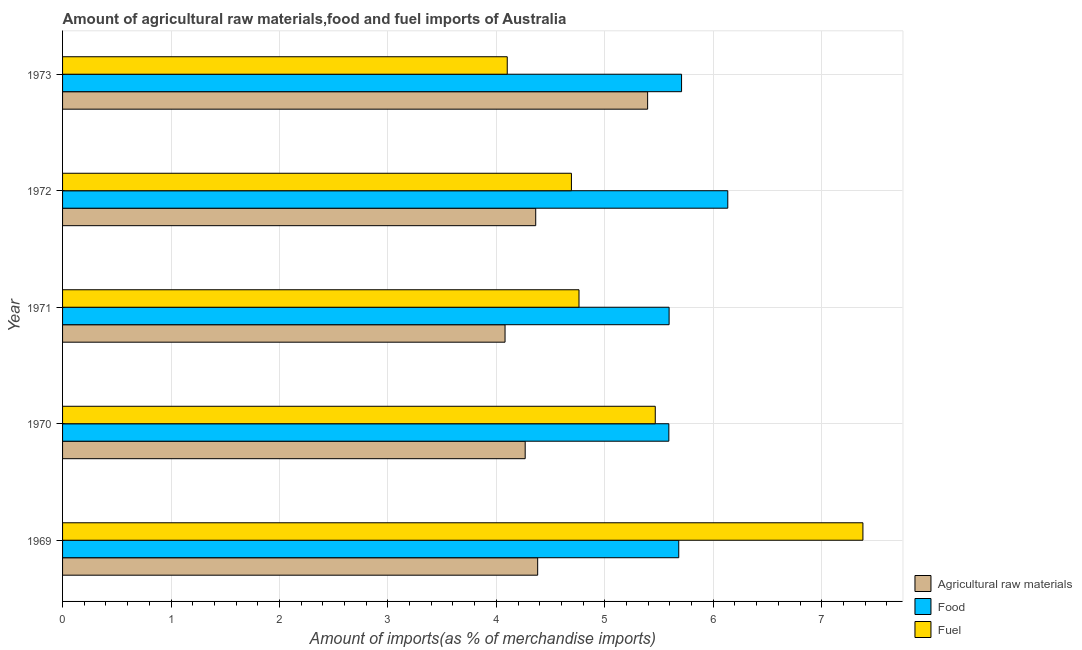How many groups of bars are there?
Keep it short and to the point. 5. Are the number of bars per tick equal to the number of legend labels?
Make the answer very short. Yes. How many bars are there on the 1st tick from the top?
Offer a terse response. 3. How many bars are there on the 4th tick from the bottom?
Keep it short and to the point. 3. What is the label of the 1st group of bars from the top?
Give a very brief answer. 1973. What is the percentage of fuel imports in 1972?
Your response must be concise. 4.69. Across all years, what is the maximum percentage of food imports?
Provide a short and direct response. 6.13. Across all years, what is the minimum percentage of fuel imports?
Provide a short and direct response. 4.1. In which year was the percentage of fuel imports maximum?
Offer a terse response. 1969. What is the total percentage of fuel imports in the graph?
Ensure brevity in your answer.  26.4. What is the difference between the percentage of raw materials imports in 1970 and that in 1971?
Ensure brevity in your answer.  0.19. What is the difference between the percentage of raw materials imports in 1971 and the percentage of fuel imports in 1973?
Provide a short and direct response. -0.02. What is the average percentage of raw materials imports per year?
Offer a very short reply. 4.5. In the year 1973, what is the difference between the percentage of food imports and percentage of raw materials imports?
Give a very brief answer. 0.31. In how many years, is the percentage of raw materials imports greater than 1.6 %?
Give a very brief answer. 5. What is the ratio of the percentage of food imports in 1970 to that in 1972?
Offer a terse response. 0.91. Is the difference between the percentage of food imports in 1969 and 1971 greater than the difference between the percentage of raw materials imports in 1969 and 1971?
Your answer should be very brief. No. What is the difference between the highest and the second highest percentage of food imports?
Your response must be concise. 0.43. What is the difference between the highest and the lowest percentage of fuel imports?
Your answer should be compact. 3.28. Is the sum of the percentage of food imports in 1971 and 1972 greater than the maximum percentage of raw materials imports across all years?
Provide a short and direct response. Yes. What does the 2nd bar from the top in 1970 represents?
Your response must be concise. Food. What does the 3rd bar from the bottom in 1971 represents?
Your answer should be very brief. Fuel. Is it the case that in every year, the sum of the percentage of raw materials imports and percentage of food imports is greater than the percentage of fuel imports?
Your answer should be very brief. Yes. How many bars are there?
Provide a short and direct response. 15. How many years are there in the graph?
Make the answer very short. 5. What is the difference between two consecutive major ticks on the X-axis?
Make the answer very short. 1. Are the values on the major ticks of X-axis written in scientific E-notation?
Make the answer very short. No. Does the graph contain any zero values?
Give a very brief answer. No. Does the graph contain grids?
Ensure brevity in your answer.  Yes. How many legend labels are there?
Offer a very short reply. 3. How are the legend labels stacked?
Give a very brief answer. Vertical. What is the title of the graph?
Your answer should be very brief. Amount of agricultural raw materials,food and fuel imports of Australia. Does "Domestic economy" appear as one of the legend labels in the graph?
Offer a terse response. No. What is the label or title of the X-axis?
Your response must be concise. Amount of imports(as % of merchandise imports). What is the label or title of the Y-axis?
Offer a terse response. Year. What is the Amount of imports(as % of merchandise imports) of Agricultural raw materials in 1969?
Offer a very short reply. 4.38. What is the Amount of imports(as % of merchandise imports) of Food in 1969?
Provide a short and direct response. 5.68. What is the Amount of imports(as % of merchandise imports) in Fuel in 1969?
Your answer should be very brief. 7.38. What is the Amount of imports(as % of merchandise imports) of Agricultural raw materials in 1970?
Offer a very short reply. 4.27. What is the Amount of imports(as % of merchandise imports) of Food in 1970?
Keep it short and to the point. 5.59. What is the Amount of imports(as % of merchandise imports) of Fuel in 1970?
Keep it short and to the point. 5.47. What is the Amount of imports(as % of merchandise imports) of Agricultural raw materials in 1971?
Offer a terse response. 4.08. What is the Amount of imports(as % of merchandise imports) in Food in 1971?
Offer a terse response. 5.59. What is the Amount of imports(as % of merchandise imports) in Fuel in 1971?
Make the answer very short. 4.76. What is the Amount of imports(as % of merchandise imports) of Agricultural raw materials in 1972?
Keep it short and to the point. 4.36. What is the Amount of imports(as % of merchandise imports) in Food in 1972?
Your answer should be very brief. 6.13. What is the Amount of imports(as % of merchandise imports) in Fuel in 1972?
Your response must be concise. 4.69. What is the Amount of imports(as % of merchandise imports) in Agricultural raw materials in 1973?
Offer a very short reply. 5.39. What is the Amount of imports(as % of merchandise imports) of Food in 1973?
Keep it short and to the point. 5.71. What is the Amount of imports(as % of merchandise imports) of Fuel in 1973?
Ensure brevity in your answer.  4.1. Across all years, what is the maximum Amount of imports(as % of merchandise imports) in Agricultural raw materials?
Offer a terse response. 5.39. Across all years, what is the maximum Amount of imports(as % of merchandise imports) in Food?
Your answer should be very brief. 6.13. Across all years, what is the maximum Amount of imports(as % of merchandise imports) in Fuel?
Your answer should be very brief. 7.38. Across all years, what is the minimum Amount of imports(as % of merchandise imports) of Agricultural raw materials?
Your answer should be very brief. 4.08. Across all years, what is the minimum Amount of imports(as % of merchandise imports) in Food?
Your answer should be compact. 5.59. Across all years, what is the minimum Amount of imports(as % of merchandise imports) of Fuel?
Your response must be concise. 4.1. What is the total Amount of imports(as % of merchandise imports) of Agricultural raw materials in the graph?
Keep it short and to the point. 22.48. What is the total Amount of imports(as % of merchandise imports) in Food in the graph?
Ensure brevity in your answer.  28.71. What is the total Amount of imports(as % of merchandise imports) in Fuel in the graph?
Your answer should be compact. 26.4. What is the difference between the Amount of imports(as % of merchandise imports) in Agricultural raw materials in 1969 and that in 1970?
Keep it short and to the point. 0.12. What is the difference between the Amount of imports(as % of merchandise imports) in Food in 1969 and that in 1970?
Your answer should be compact. 0.09. What is the difference between the Amount of imports(as % of merchandise imports) of Fuel in 1969 and that in 1970?
Ensure brevity in your answer.  1.91. What is the difference between the Amount of imports(as % of merchandise imports) of Agricultural raw materials in 1969 and that in 1971?
Keep it short and to the point. 0.3. What is the difference between the Amount of imports(as % of merchandise imports) of Food in 1969 and that in 1971?
Your answer should be very brief. 0.09. What is the difference between the Amount of imports(as % of merchandise imports) in Fuel in 1969 and that in 1971?
Ensure brevity in your answer.  2.62. What is the difference between the Amount of imports(as % of merchandise imports) in Agricultural raw materials in 1969 and that in 1972?
Keep it short and to the point. 0.02. What is the difference between the Amount of imports(as % of merchandise imports) of Food in 1969 and that in 1972?
Give a very brief answer. -0.45. What is the difference between the Amount of imports(as % of merchandise imports) in Fuel in 1969 and that in 1972?
Your answer should be very brief. 2.69. What is the difference between the Amount of imports(as % of merchandise imports) in Agricultural raw materials in 1969 and that in 1973?
Make the answer very short. -1.01. What is the difference between the Amount of imports(as % of merchandise imports) in Food in 1969 and that in 1973?
Ensure brevity in your answer.  -0.03. What is the difference between the Amount of imports(as % of merchandise imports) of Fuel in 1969 and that in 1973?
Offer a terse response. 3.28. What is the difference between the Amount of imports(as % of merchandise imports) in Agricultural raw materials in 1970 and that in 1971?
Give a very brief answer. 0.19. What is the difference between the Amount of imports(as % of merchandise imports) in Food in 1970 and that in 1971?
Your answer should be very brief. -0. What is the difference between the Amount of imports(as % of merchandise imports) in Fuel in 1970 and that in 1971?
Provide a short and direct response. 0.7. What is the difference between the Amount of imports(as % of merchandise imports) of Agricultural raw materials in 1970 and that in 1972?
Keep it short and to the point. -0.1. What is the difference between the Amount of imports(as % of merchandise imports) of Food in 1970 and that in 1972?
Provide a succinct answer. -0.54. What is the difference between the Amount of imports(as % of merchandise imports) of Fuel in 1970 and that in 1972?
Your response must be concise. 0.77. What is the difference between the Amount of imports(as % of merchandise imports) in Agricultural raw materials in 1970 and that in 1973?
Make the answer very short. -1.13. What is the difference between the Amount of imports(as % of merchandise imports) of Food in 1970 and that in 1973?
Make the answer very short. -0.12. What is the difference between the Amount of imports(as % of merchandise imports) of Fuel in 1970 and that in 1973?
Your answer should be compact. 1.36. What is the difference between the Amount of imports(as % of merchandise imports) in Agricultural raw materials in 1971 and that in 1972?
Ensure brevity in your answer.  -0.28. What is the difference between the Amount of imports(as % of merchandise imports) of Food in 1971 and that in 1972?
Your answer should be compact. -0.54. What is the difference between the Amount of imports(as % of merchandise imports) of Fuel in 1971 and that in 1972?
Make the answer very short. 0.07. What is the difference between the Amount of imports(as % of merchandise imports) in Agricultural raw materials in 1971 and that in 1973?
Give a very brief answer. -1.31. What is the difference between the Amount of imports(as % of merchandise imports) in Food in 1971 and that in 1973?
Offer a terse response. -0.11. What is the difference between the Amount of imports(as % of merchandise imports) in Fuel in 1971 and that in 1973?
Give a very brief answer. 0.66. What is the difference between the Amount of imports(as % of merchandise imports) of Agricultural raw materials in 1972 and that in 1973?
Your answer should be very brief. -1.03. What is the difference between the Amount of imports(as % of merchandise imports) in Food in 1972 and that in 1973?
Provide a short and direct response. 0.43. What is the difference between the Amount of imports(as % of merchandise imports) in Fuel in 1972 and that in 1973?
Keep it short and to the point. 0.59. What is the difference between the Amount of imports(as % of merchandise imports) in Agricultural raw materials in 1969 and the Amount of imports(as % of merchandise imports) in Food in 1970?
Your response must be concise. -1.21. What is the difference between the Amount of imports(as % of merchandise imports) of Agricultural raw materials in 1969 and the Amount of imports(as % of merchandise imports) of Fuel in 1970?
Offer a terse response. -1.08. What is the difference between the Amount of imports(as % of merchandise imports) of Food in 1969 and the Amount of imports(as % of merchandise imports) of Fuel in 1970?
Keep it short and to the point. 0.22. What is the difference between the Amount of imports(as % of merchandise imports) in Agricultural raw materials in 1969 and the Amount of imports(as % of merchandise imports) in Food in 1971?
Provide a succinct answer. -1.21. What is the difference between the Amount of imports(as % of merchandise imports) of Agricultural raw materials in 1969 and the Amount of imports(as % of merchandise imports) of Fuel in 1971?
Provide a succinct answer. -0.38. What is the difference between the Amount of imports(as % of merchandise imports) in Food in 1969 and the Amount of imports(as % of merchandise imports) in Fuel in 1971?
Keep it short and to the point. 0.92. What is the difference between the Amount of imports(as % of merchandise imports) of Agricultural raw materials in 1969 and the Amount of imports(as % of merchandise imports) of Food in 1972?
Make the answer very short. -1.75. What is the difference between the Amount of imports(as % of merchandise imports) of Agricultural raw materials in 1969 and the Amount of imports(as % of merchandise imports) of Fuel in 1972?
Provide a short and direct response. -0.31. What is the difference between the Amount of imports(as % of merchandise imports) in Agricultural raw materials in 1969 and the Amount of imports(as % of merchandise imports) in Food in 1973?
Offer a terse response. -1.33. What is the difference between the Amount of imports(as % of merchandise imports) in Agricultural raw materials in 1969 and the Amount of imports(as % of merchandise imports) in Fuel in 1973?
Provide a succinct answer. 0.28. What is the difference between the Amount of imports(as % of merchandise imports) of Food in 1969 and the Amount of imports(as % of merchandise imports) of Fuel in 1973?
Make the answer very short. 1.58. What is the difference between the Amount of imports(as % of merchandise imports) of Agricultural raw materials in 1970 and the Amount of imports(as % of merchandise imports) of Food in 1971?
Offer a terse response. -1.33. What is the difference between the Amount of imports(as % of merchandise imports) in Agricultural raw materials in 1970 and the Amount of imports(as % of merchandise imports) in Fuel in 1971?
Keep it short and to the point. -0.5. What is the difference between the Amount of imports(as % of merchandise imports) of Food in 1970 and the Amount of imports(as % of merchandise imports) of Fuel in 1971?
Your answer should be very brief. 0.83. What is the difference between the Amount of imports(as % of merchandise imports) in Agricultural raw materials in 1970 and the Amount of imports(as % of merchandise imports) in Food in 1972?
Your response must be concise. -1.87. What is the difference between the Amount of imports(as % of merchandise imports) in Agricultural raw materials in 1970 and the Amount of imports(as % of merchandise imports) in Fuel in 1972?
Offer a very short reply. -0.43. What is the difference between the Amount of imports(as % of merchandise imports) in Food in 1970 and the Amount of imports(as % of merchandise imports) in Fuel in 1972?
Ensure brevity in your answer.  0.9. What is the difference between the Amount of imports(as % of merchandise imports) in Agricultural raw materials in 1970 and the Amount of imports(as % of merchandise imports) in Food in 1973?
Keep it short and to the point. -1.44. What is the difference between the Amount of imports(as % of merchandise imports) of Agricultural raw materials in 1970 and the Amount of imports(as % of merchandise imports) of Fuel in 1973?
Offer a very short reply. 0.17. What is the difference between the Amount of imports(as % of merchandise imports) of Food in 1970 and the Amount of imports(as % of merchandise imports) of Fuel in 1973?
Give a very brief answer. 1.49. What is the difference between the Amount of imports(as % of merchandise imports) in Agricultural raw materials in 1971 and the Amount of imports(as % of merchandise imports) in Food in 1972?
Your response must be concise. -2.05. What is the difference between the Amount of imports(as % of merchandise imports) of Agricultural raw materials in 1971 and the Amount of imports(as % of merchandise imports) of Fuel in 1972?
Provide a succinct answer. -0.61. What is the difference between the Amount of imports(as % of merchandise imports) in Food in 1971 and the Amount of imports(as % of merchandise imports) in Fuel in 1972?
Your answer should be compact. 0.9. What is the difference between the Amount of imports(as % of merchandise imports) of Agricultural raw materials in 1971 and the Amount of imports(as % of merchandise imports) of Food in 1973?
Provide a succinct answer. -1.63. What is the difference between the Amount of imports(as % of merchandise imports) of Agricultural raw materials in 1971 and the Amount of imports(as % of merchandise imports) of Fuel in 1973?
Offer a terse response. -0.02. What is the difference between the Amount of imports(as % of merchandise imports) in Food in 1971 and the Amount of imports(as % of merchandise imports) in Fuel in 1973?
Keep it short and to the point. 1.49. What is the difference between the Amount of imports(as % of merchandise imports) in Agricultural raw materials in 1972 and the Amount of imports(as % of merchandise imports) in Food in 1973?
Offer a very short reply. -1.34. What is the difference between the Amount of imports(as % of merchandise imports) in Agricultural raw materials in 1972 and the Amount of imports(as % of merchandise imports) in Fuel in 1973?
Provide a succinct answer. 0.26. What is the difference between the Amount of imports(as % of merchandise imports) in Food in 1972 and the Amount of imports(as % of merchandise imports) in Fuel in 1973?
Provide a succinct answer. 2.03. What is the average Amount of imports(as % of merchandise imports) in Agricultural raw materials per year?
Give a very brief answer. 4.5. What is the average Amount of imports(as % of merchandise imports) in Food per year?
Give a very brief answer. 5.74. What is the average Amount of imports(as % of merchandise imports) in Fuel per year?
Provide a succinct answer. 5.28. In the year 1969, what is the difference between the Amount of imports(as % of merchandise imports) of Agricultural raw materials and Amount of imports(as % of merchandise imports) of Food?
Offer a very short reply. -1.3. In the year 1969, what is the difference between the Amount of imports(as % of merchandise imports) in Agricultural raw materials and Amount of imports(as % of merchandise imports) in Fuel?
Your answer should be compact. -3. In the year 1969, what is the difference between the Amount of imports(as % of merchandise imports) in Food and Amount of imports(as % of merchandise imports) in Fuel?
Make the answer very short. -1.7. In the year 1970, what is the difference between the Amount of imports(as % of merchandise imports) of Agricultural raw materials and Amount of imports(as % of merchandise imports) of Food?
Ensure brevity in your answer.  -1.32. In the year 1970, what is the difference between the Amount of imports(as % of merchandise imports) in Agricultural raw materials and Amount of imports(as % of merchandise imports) in Fuel?
Your response must be concise. -1.2. In the year 1970, what is the difference between the Amount of imports(as % of merchandise imports) of Food and Amount of imports(as % of merchandise imports) of Fuel?
Provide a short and direct response. 0.13. In the year 1971, what is the difference between the Amount of imports(as % of merchandise imports) in Agricultural raw materials and Amount of imports(as % of merchandise imports) in Food?
Offer a terse response. -1.51. In the year 1971, what is the difference between the Amount of imports(as % of merchandise imports) of Agricultural raw materials and Amount of imports(as % of merchandise imports) of Fuel?
Provide a succinct answer. -0.68. In the year 1971, what is the difference between the Amount of imports(as % of merchandise imports) of Food and Amount of imports(as % of merchandise imports) of Fuel?
Make the answer very short. 0.83. In the year 1972, what is the difference between the Amount of imports(as % of merchandise imports) of Agricultural raw materials and Amount of imports(as % of merchandise imports) of Food?
Give a very brief answer. -1.77. In the year 1972, what is the difference between the Amount of imports(as % of merchandise imports) in Agricultural raw materials and Amount of imports(as % of merchandise imports) in Fuel?
Provide a short and direct response. -0.33. In the year 1972, what is the difference between the Amount of imports(as % of merchandise imports) in Food and Amount of imports(as % of merchandise imports) in Fuel?
Offer a terse response. 1.44. In the year 1973, what is the difference between the Amount of imports(as % of merchandise imports) of Agricultural raw materials and Amount of imports(as % of merchandise imports) of Food?
Provide a short and direct response. -0.31. In the year 1973, what is the difference between the Amount of imports(as % of merchandise imports) of Agricultural raw materials and Amount of imports(as % of merchandise imports) of Fuel?
Make the answer very short. 1.29. In the year 1973, what is the difference between the Amount of imports(as % of merchandise imports) in Food and Amount of imports(as % of merchandise imports) in Fuel?
Keep it short and to the point. 1.61. What is the ratio of the Amount of imports(as % of merchandise imports) in Food in 1969 to that in 1970?
Give a very brief answer. 1.02. What is the ratio of the Amount of imports(as % of merchandise imports) of Fuel in 1969 to that in 1970?
Keep it short and to the point. 1.35. What is the ratio of the Amount of imports(as % of merchandise imports) in Agricultural raw materials in 1969 to that in 1971?
Your answer should be very brief. 1.07. What is the ratio of the Amount of imports(as % of merchandise imports) in Food in 1969 to that in 1971?
Your answer should be very brief. 1.02. What is the ratio of the Amount of imports(as % of merchandise imports) of Fuel in 1969 to that in 1971?
Offer a terse response. 1.55. What is the ratio of the Amount of imports(as % of merchandise imports) in Agricultural raw materials in 1969 to that in 1972?
Your response must be concise. 1. What is the ratio of the Amount of imports(as % of merchandise imports) in Food in 1969 to that in 1972?
Give a very brief answer. 0.93. What is the ratio of the Amount of imports(as % of merchandise imports) in Fuel in 1969 to that in 1972?
Offer a very short reply. 1.57. What is the ratio of the Amount of imports(as % of merchandise imports) in Agricultural raw materials in 1969 to that in 1973?
Ensure brevity in your answer.  0.81. What is the ratio of the Amount of imports(as % of merchandise imports) of Food in 1969 to that in 1973?
Give a very brief answer. 1. What is the ratio of the Amount of imports(as % of merchandise imports) in Fuel in 1969 to that in 1973?
Provide a short and direct response. 1.8. What is the ratio of the Amount of imports(as % of merchandise imports) in Agricultural raw materials in 1970 to that in 1971?
Make the answer very short. 1.05. What is the ratio of the Amount of imports(as % of merchandise imports) of Fuel in 1970 to that in 1971?
Provide a succinct answer. 1.15. What is the ratio of the Amount of imports(as % of merchandise imports) of Agricultural raw materials in 1970 to that in 1972?
Give a very brief answer. 0.98. What is the ratio of the Amount of imports(as % of merchandise imports) in Food in 1970 to that in 1972?
Provide a succinct answer. 0.91. What is the ratio of the Amount of imports(as % of merchandise imports) of Fuel in 1970 to that in 1972?
Make the answer very short. 1.16. What is the ratio of the Amount of imports(as % of merchandise imports) of Agricultural raw materials in 1970 to that in 1973?
Your response must be concise. 0.79. What is the ratio of the Amount of imports(as % of merchandise imports) of Food in 1970 to that in 1973?
Make the answer very short. 0.98. What is the ratio of the Amount of imports(as % of merchandise imports) of Fuel in 1970 to that in 1973?
Your response must be concise. 1.33. What is the ratio of the Amount of imports(as % of merchandise imports) of Agricultural raw materials in 1971 to that in 1972?
Your answer should be compact. 0.94. What is the ratio of the Amount of imports(as % of merchandise imports) in Food in 1971 to that in 1972?
Provide a succinct answer. 0.91. What is the ratio of the Amount of imports(as % of merchandise imports) of Fuel in 1971 to that in 1972?
Make the answer very short. 1.01. What is the ratio of the Amount of imports(as % of merchandise imports) of Agricultural raw materials in 1971 to that in 1973?
Make the answer very short. 0.76. What is the ratio of the Amount of imports(as % of merchandise imports) in Food in 1971 to that in 1973?
Make the answer very short. 0.98. What is the ratio of the Amount of imports(as % of merchandise imports) in Fuel in 1971 to that in 1973?
Give a very brief answer. 1.16. What is the ratio of the Amount of imports(as % of merchandise imports) of Agricultural raw materials in 1972 to that in 1973?
Make the answer very short. 0.81. What is the ratio of the Amount of imports(as % of merchandise imports) in Food in 1972 to that in 1973?
Provide a succinct answer. 1.07. What is the ratio of the Amount of imports(as % of merchandise imports) of Fuel in 1972 to that in 1973?
Provide a succinct answer. 1.14. What is the difference between the highest and the second highest Amount of imports(as % of merchandise imports) of Agricultural raw materials?
Keep it short and to the point. 1.01. What is the difference between the highest and the second highest Amount of imports(as % of merchandise imports) of Food?
Give a very brief answer. 0.43. What is the difference between the highest and the second highest Amount of imports(as % of merchandise imports) of Fuel?
Ensure brevity in your answer.  1.91. What is the difference between the highest and the lowest Amount of imports(as % of merchandise imports) of Agricultural raw materials?
Offer a terse response. 1.31. What is the difference between the highest and the lowest Amount of imports(as % of merchandise imports) of Food?
Keep it short and to the point. 0.54. What is the difference between the highest and the lowest Amount of imports(as % of merchandise imports) in Fuel?
Provide a succinct answer. 3.28. 